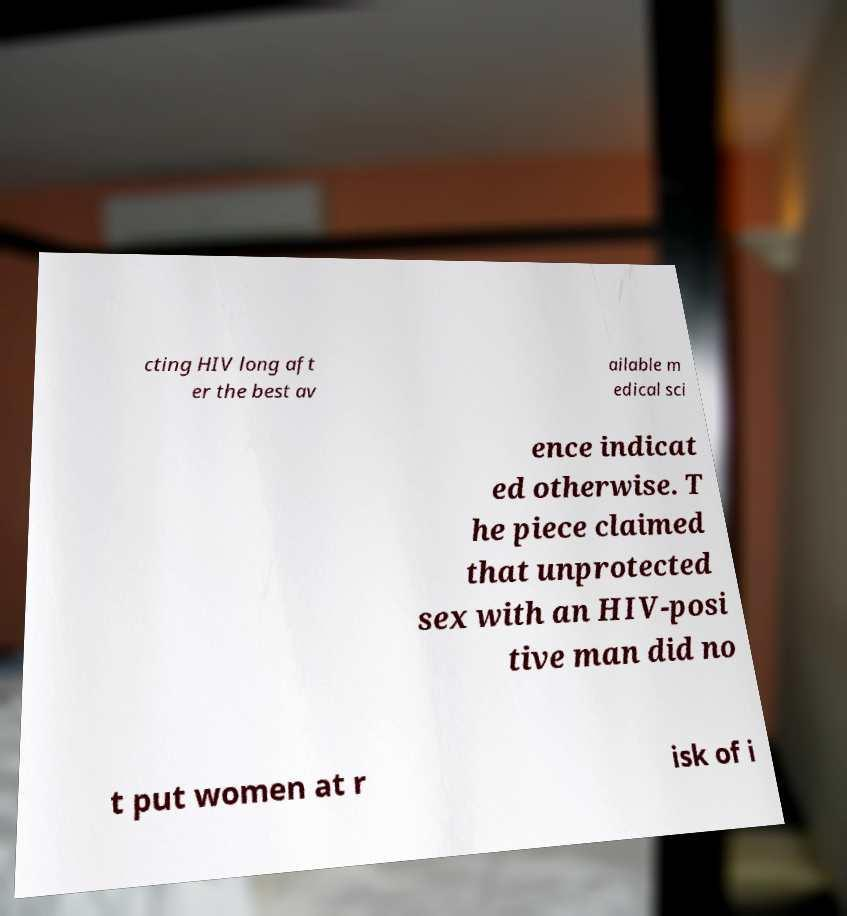Could you extract and type out the text from this image? cting HIV long aft er the best av ailable m edical sci ence indicat ed otherwise. T he piece claimed that unprotected sex with an HIV-posi tive man did no t put women at r isk of i 